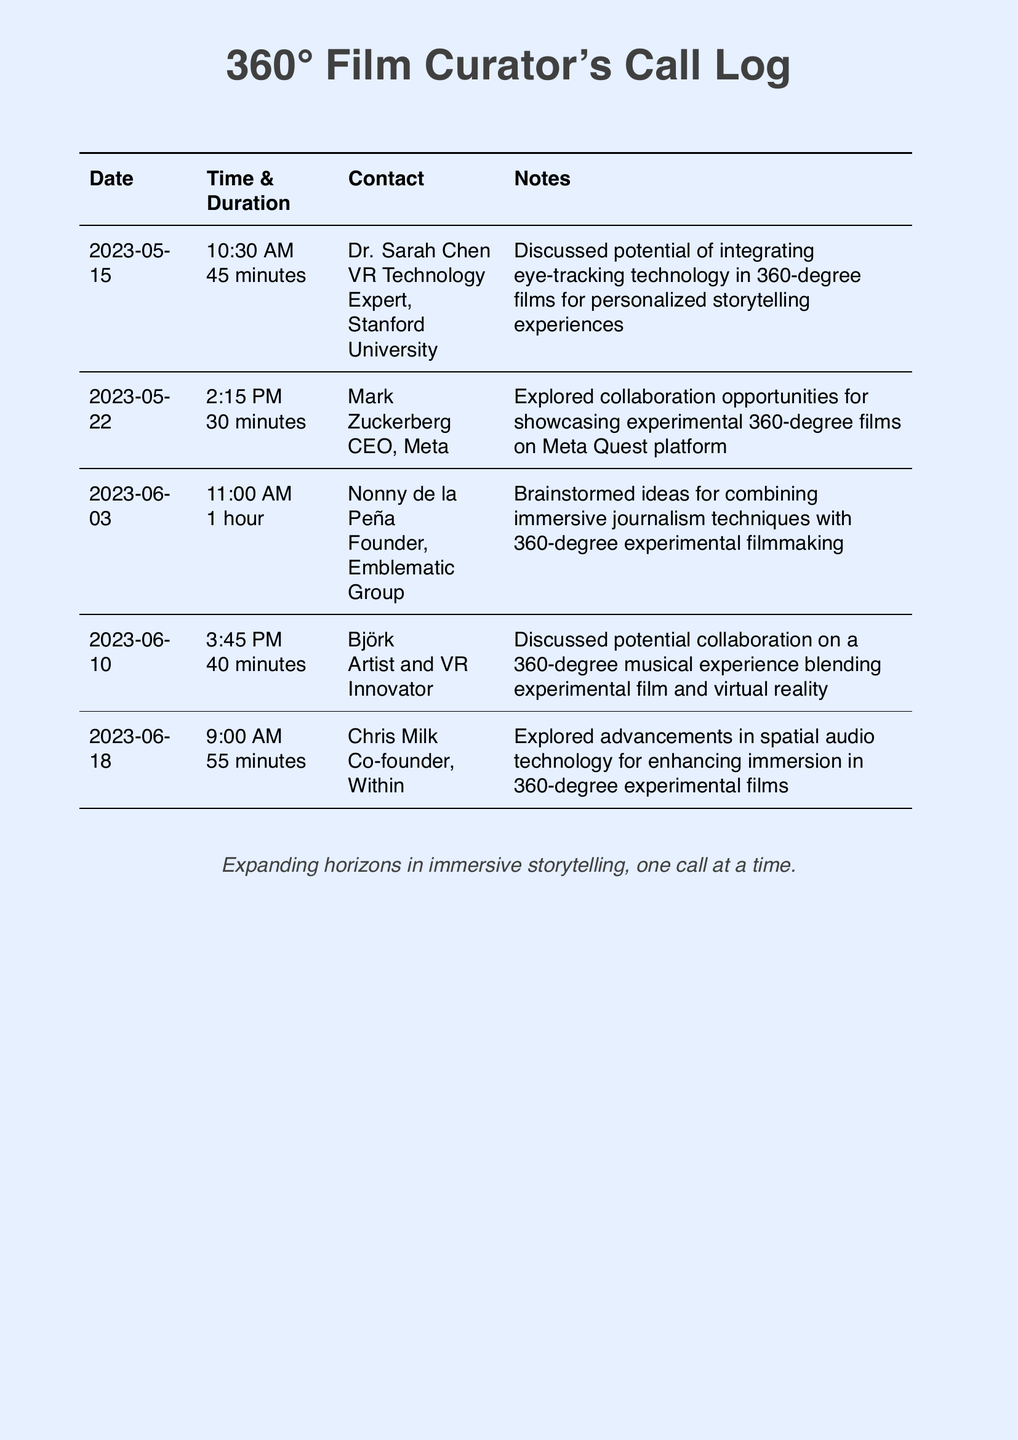What is the date of the first call? The first call is recorded on 2023-05-15.
Answer: 2023-05-15 Who did the curator speak to on June 10th? The curator spoke to Björk, an Artist and VR Innovator.
Answer: Björk How long was the call with Chris Milk? The call with Chris Milk lasted for 55 minutes.
Answer: 55 minutes What technology was discussed in the call with Dr. Sarah Chen? Eye-tracking technology was discussed for personalized storytelling experiences in 360-degree films.
Answer: Eye-tracking technology Which company does Mark Zuckerberg lead? Mark Zuckerberg is the CEO of Meta.
Answer: Meta What is the main theme of the calls recorded in this document? The main theme revolves around exploring new possibilities for immersive storytelling in 360-degree films.
Answer: Immersive storytelling How many minutes was the call with Nonny de la Peña? The call lasted for 1 hour, which is 60 minutes.
Answer: 60 minutes What subject did the curator and Chris Milk explore? They explored advancements in spatial audio technology for enhancing immersion in 360-degree experimental films.
Answer: Spatial audio technology What organization is Dr. Sarah Chen affiliated with? Dr. Sarah Chen is affiliated with Stanford University.
Answer: Stanford University 